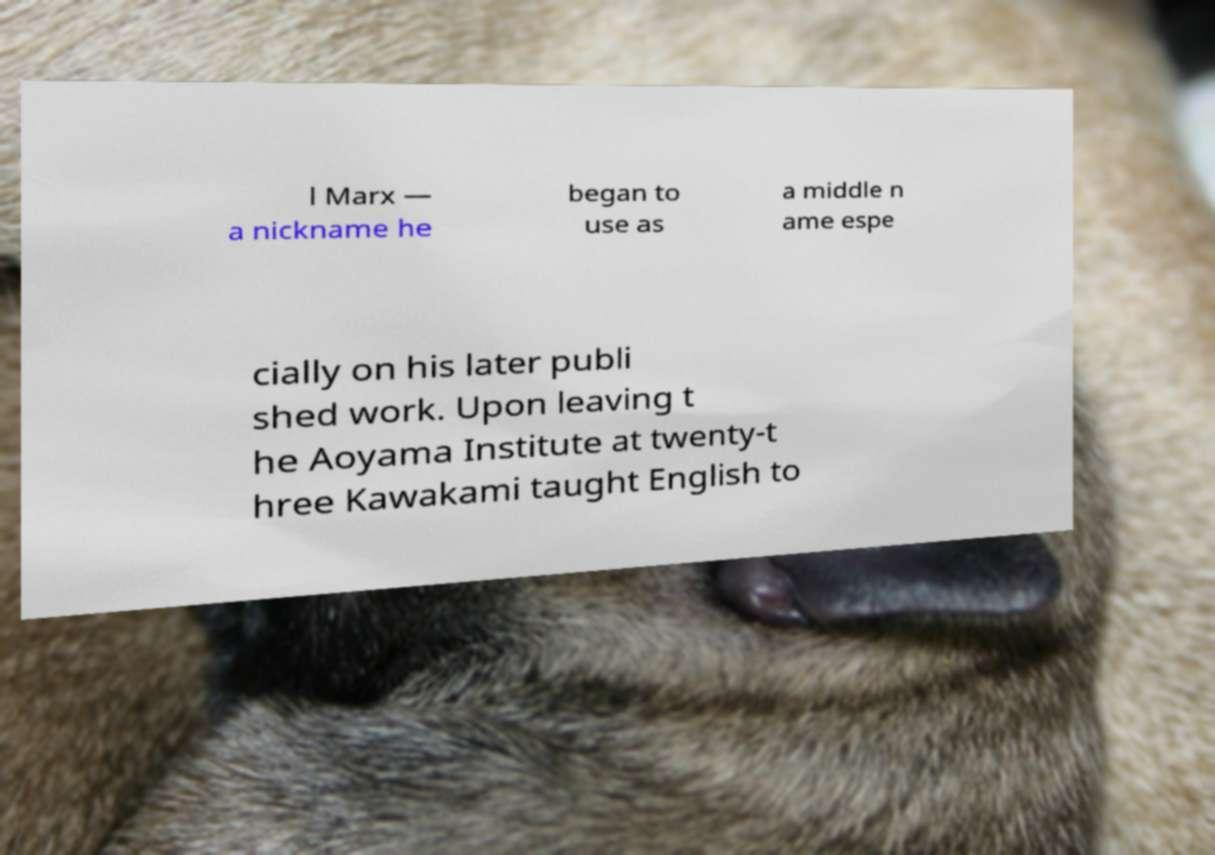For documentation purposes, I need the text within this image transcribed. Could you provide that? l Marx — a nickname he began to use as a middle n ame espe cially on his later publi shed work. Upon leaving t he Aoyama Institute at twenty-t hree Kawakami taught English to 